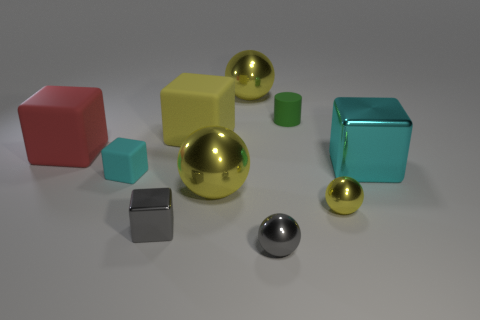Subtract all green blocks. How many yellow spheres are left? 3 Subtract 1 cubes. How many cubes are left? 4 Subtract all yellow matte blocks. How many blocks are left? 4 Subtract all red blocks. How many blocks are left? 4 Subtract all blue blocks. Subtract all gray spheres. How many blocks are left? 5 Subtract all cylinders. How many objects are left? 9 Add 2 tiny yellow metal objects. How many tiny yellow metal objects are left? 3 Add 8 big rubber cylinders. How many big rubber cylinders exist? 8 Subtract 1 green cylinders. How many objects are left? 9 Subtract all yellow metallic balls. Subtract all cyan shiny objects. How many objects are left? 6 